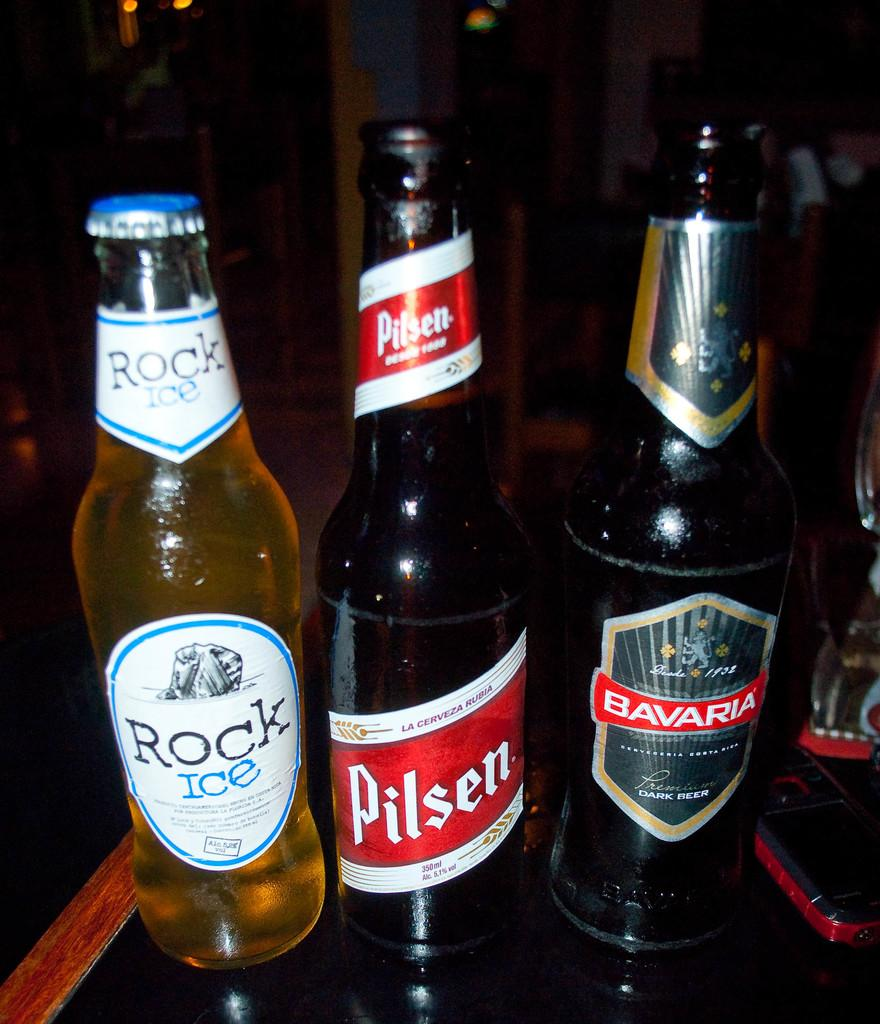<image>
Render a clear and concise summary of the photo. Three bottles of beer, the one on the left being called Rock Ice 